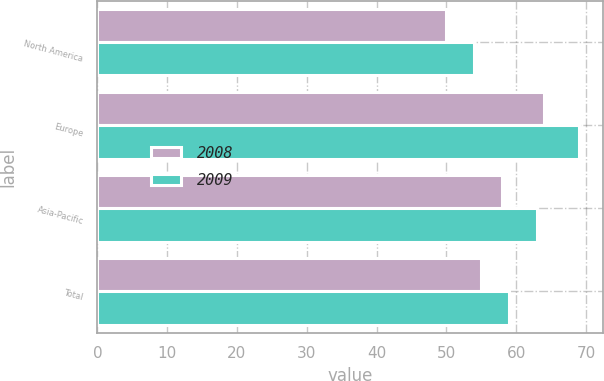Convert chart to OTSL. <chart><loc_0><loc_0><loc_500><loc_500><stacked_bar_chart><ecel><fcel>North America<fcel>Europe<fcel>Asia-Pacific<fcel>Total<nl><fcel>2008<fcel>50<fcel>64<fcel>58<fcel>55<nl><fcel>2009<fcel>54<fcel>69<fcel>63<fcel>59<nl></chart> 